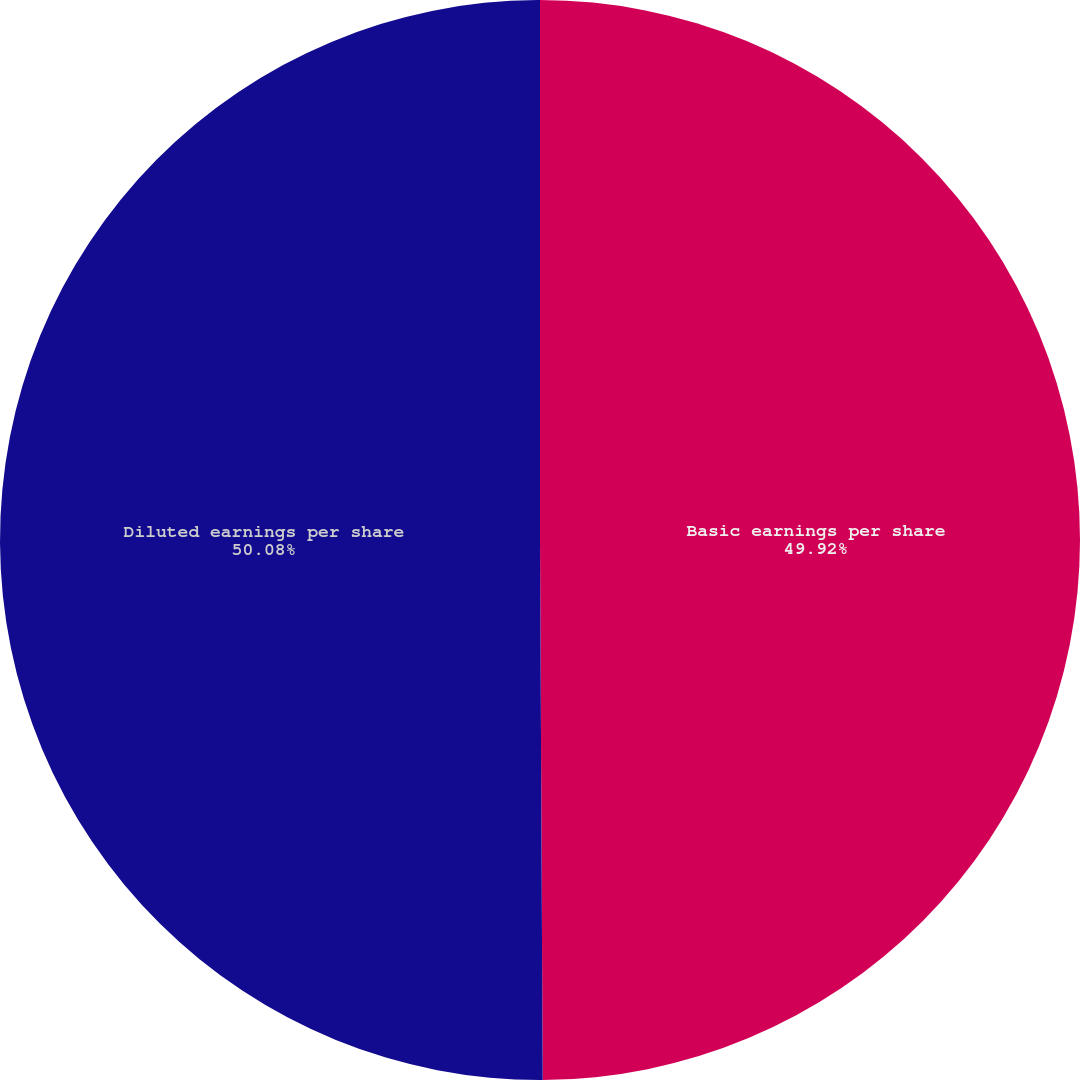Convert chart. <chart><loc_0><loc_0><loc_500><loc_500><pie_chart><fcel>Basic earnings per share<fcel>Diluted earnings per share<nl><fcel>49.92%<fcel>50.08%<nl></chart> 